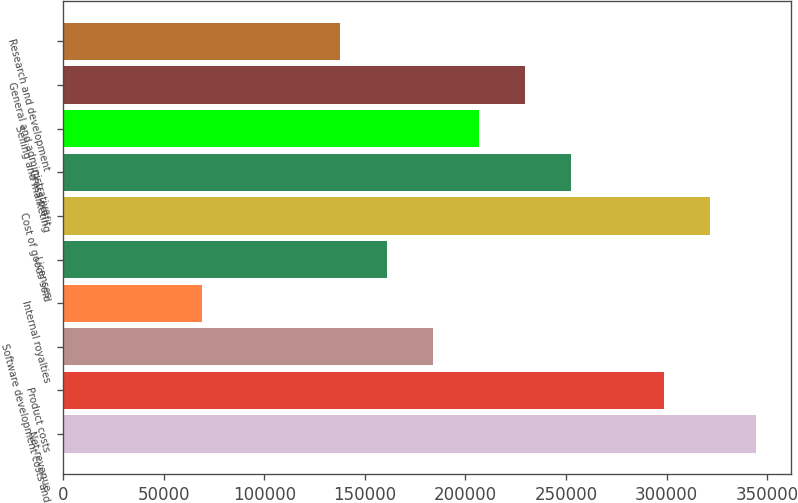<chart> <loc_0><loc_0><loc_500><loc_500><bar_chart><fcel>Net revenue<fcel>Product costs<fcel>Software development costs and<fcel>Internal royalties<fcel>Licenses<fcel>Cost of goods sold<fcel>Gross profit<fcel>Selling and marketing<fcel>General and administrative<fcel>Research and development<nl><fcel>344583<fcel>298639<fcel>183778<fcel>68916.7<fcel>160805<fcel>321611<fcel>252694<fcel>206750<fcel>229722<fcel>137833<nl></chart> 